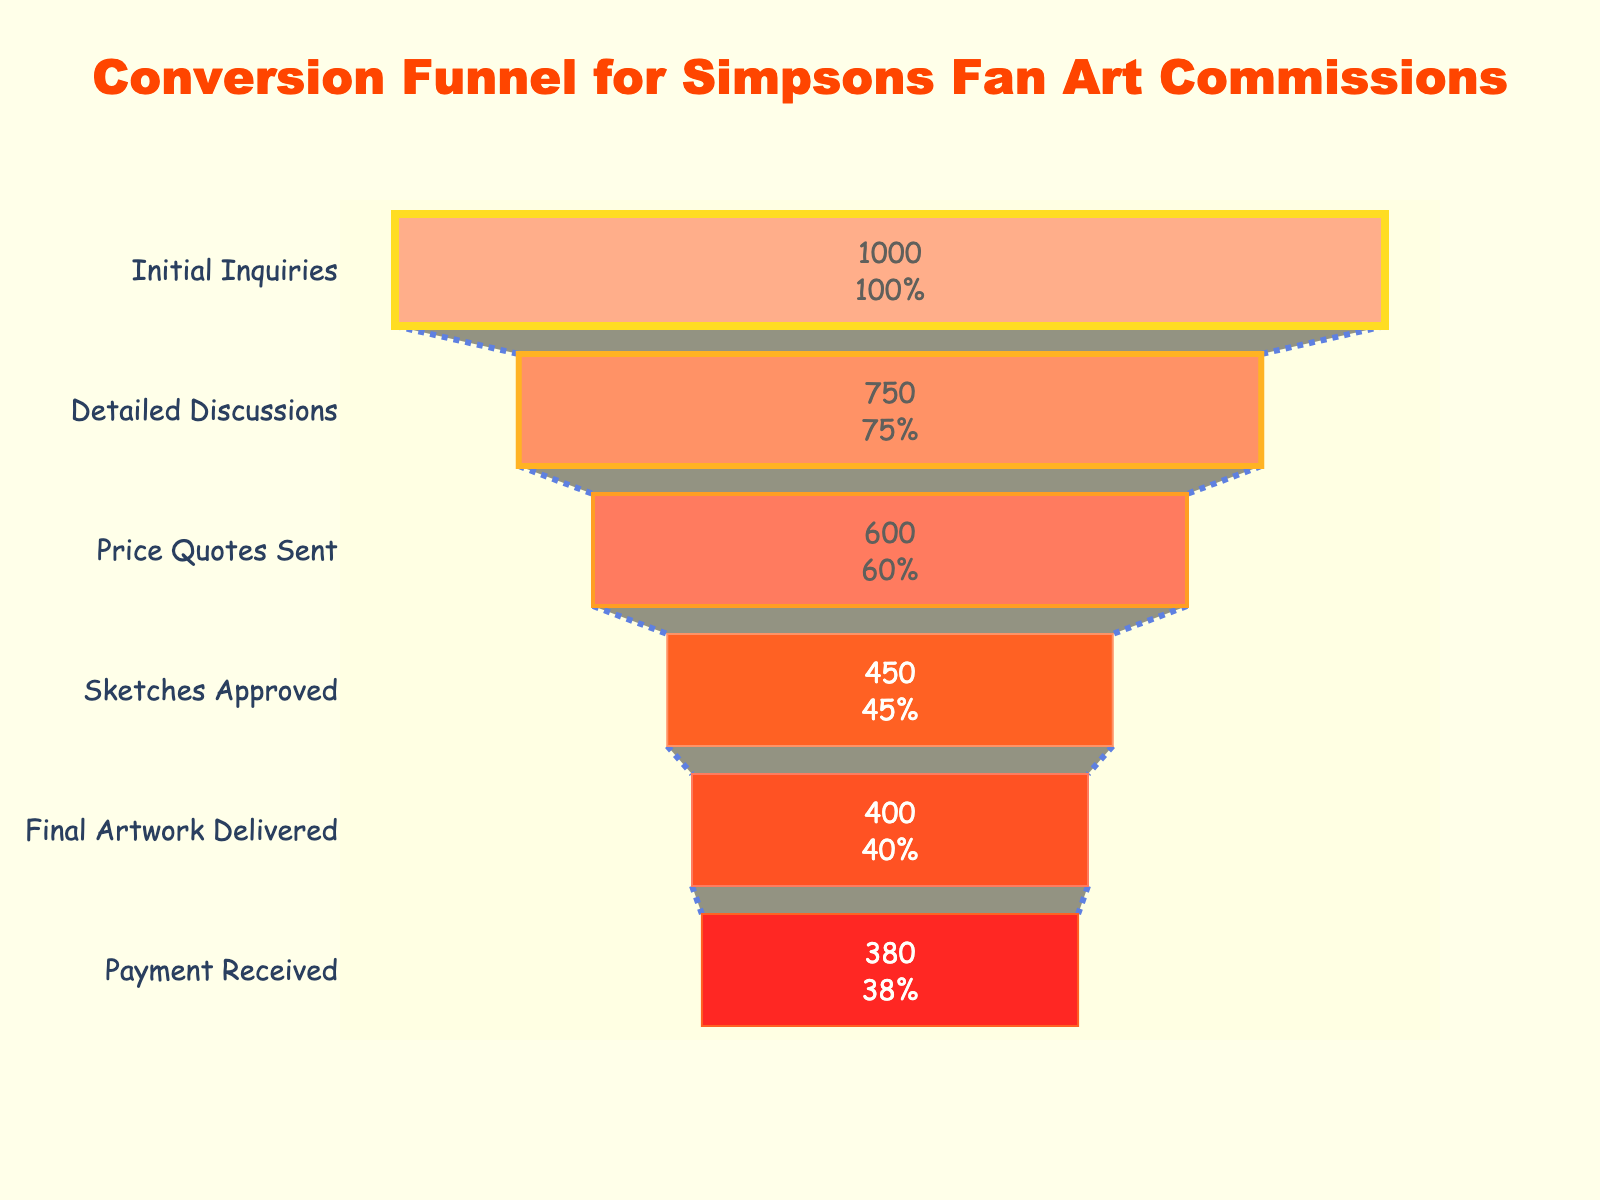What is the title of the funnel chart? The title of the chart can be found at the top center of the figure.
Answer: Conversion Funnel for Simpsons Fan Art Commissions How many stages are there in the funnel? Count the distinct stages listed on the y-axis of the funnel chart.
Answer: 6 What is the color of the 'Sketches Approved' stage? Identify the color of the bar corresponding to the 'Sketches Approved' stage in the chart.
Answer: #FF6347 What percentage of inquiries reach the 'Final Artwork Delivered' stage? The percentage can be read directly from the visual information inside the bar for 'Final Artwork Delivered'.
Answer: 40% What is the absolute number of inquiries that receive a price quote? Refer to the value displayed inside the 'Price Quotes Sent' stage in the funnel.
Answer: 600 Which stage shows the highest number of drop-offs from the previous stage? Calculate the drop-off for each stage by finding the difference between consecutive stages and identify the highest drop-off. The drop-offs are 250 (Initial Inquiries to Detailed Discussions), 150 (Detailed Discussions to Price Quotes Sent), 150 (Price Quotes Sent to Sketches Approved), 50 (Sketches Approved to Final Artwork Delivered), and 20 (Final Artwork Delivered to Payment Received). The highest drop-off is 250.
Answer: Detailed Discussions By what percentage do the inquiries reduce from 'Price Quotes Sent' to 'Sketches Approved'? Use the formula [(Price Quotes Sent - Sketches Approved) / Price Quotes Sent] * 100: [(600 - 450) / 600] * 100 = 25%.
Answer: 25% What is the overall conversion rate from initial inquiry to payment received? The conversion rate is calculated as (Payment Received / Initial Inquiries) * 100: (380 / 1000) * 100 = 38%.
Answer: 38% What stage accounts for exactly 30% of the initial inquiries? Identify the stage whose percentage value relative to 'Initial Inquiries' is displayed as 30% in the chart.
Answer: Sketches Approved How many more inquiries move from 'Final Artwork Delivered' to 'Payment Received' compared to those that drop off at the same stage? Subtract the number of 'Payment Received' from 'Final Artwork Delivered' (400 - 380 = 20). Since more inquiries drop off (20) than move forward (20), the answer is already evident.
Answer: 20 